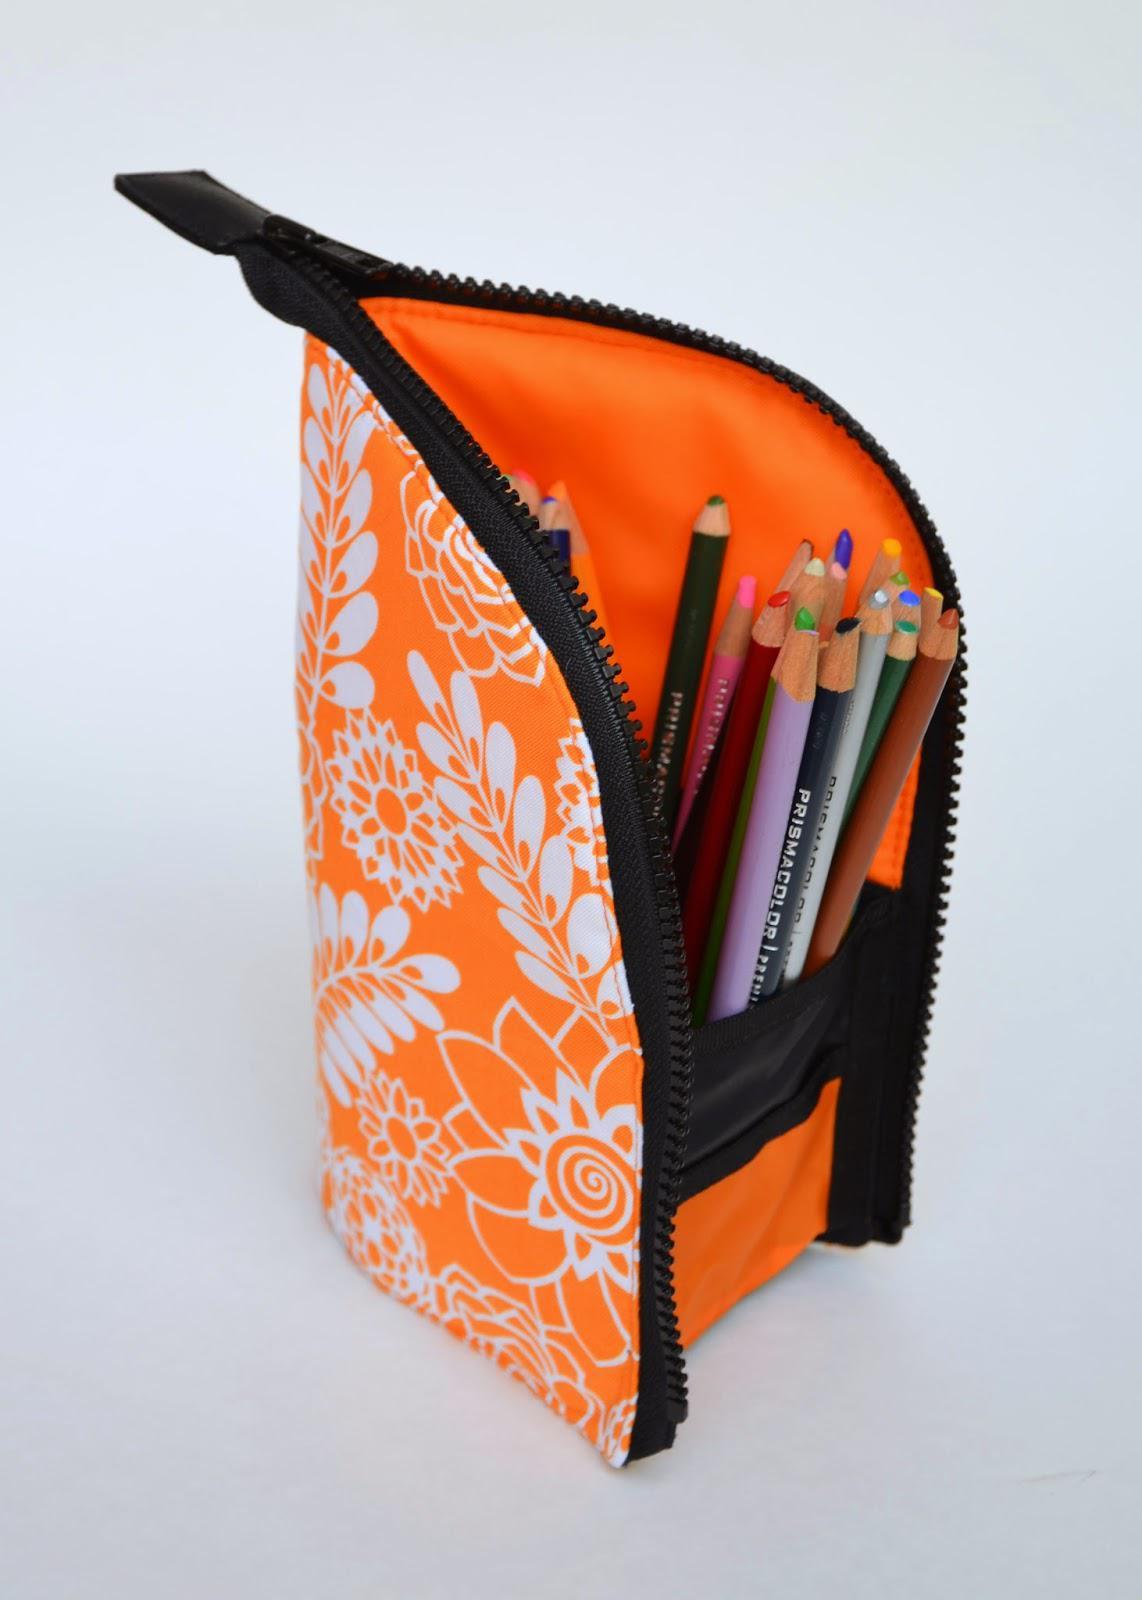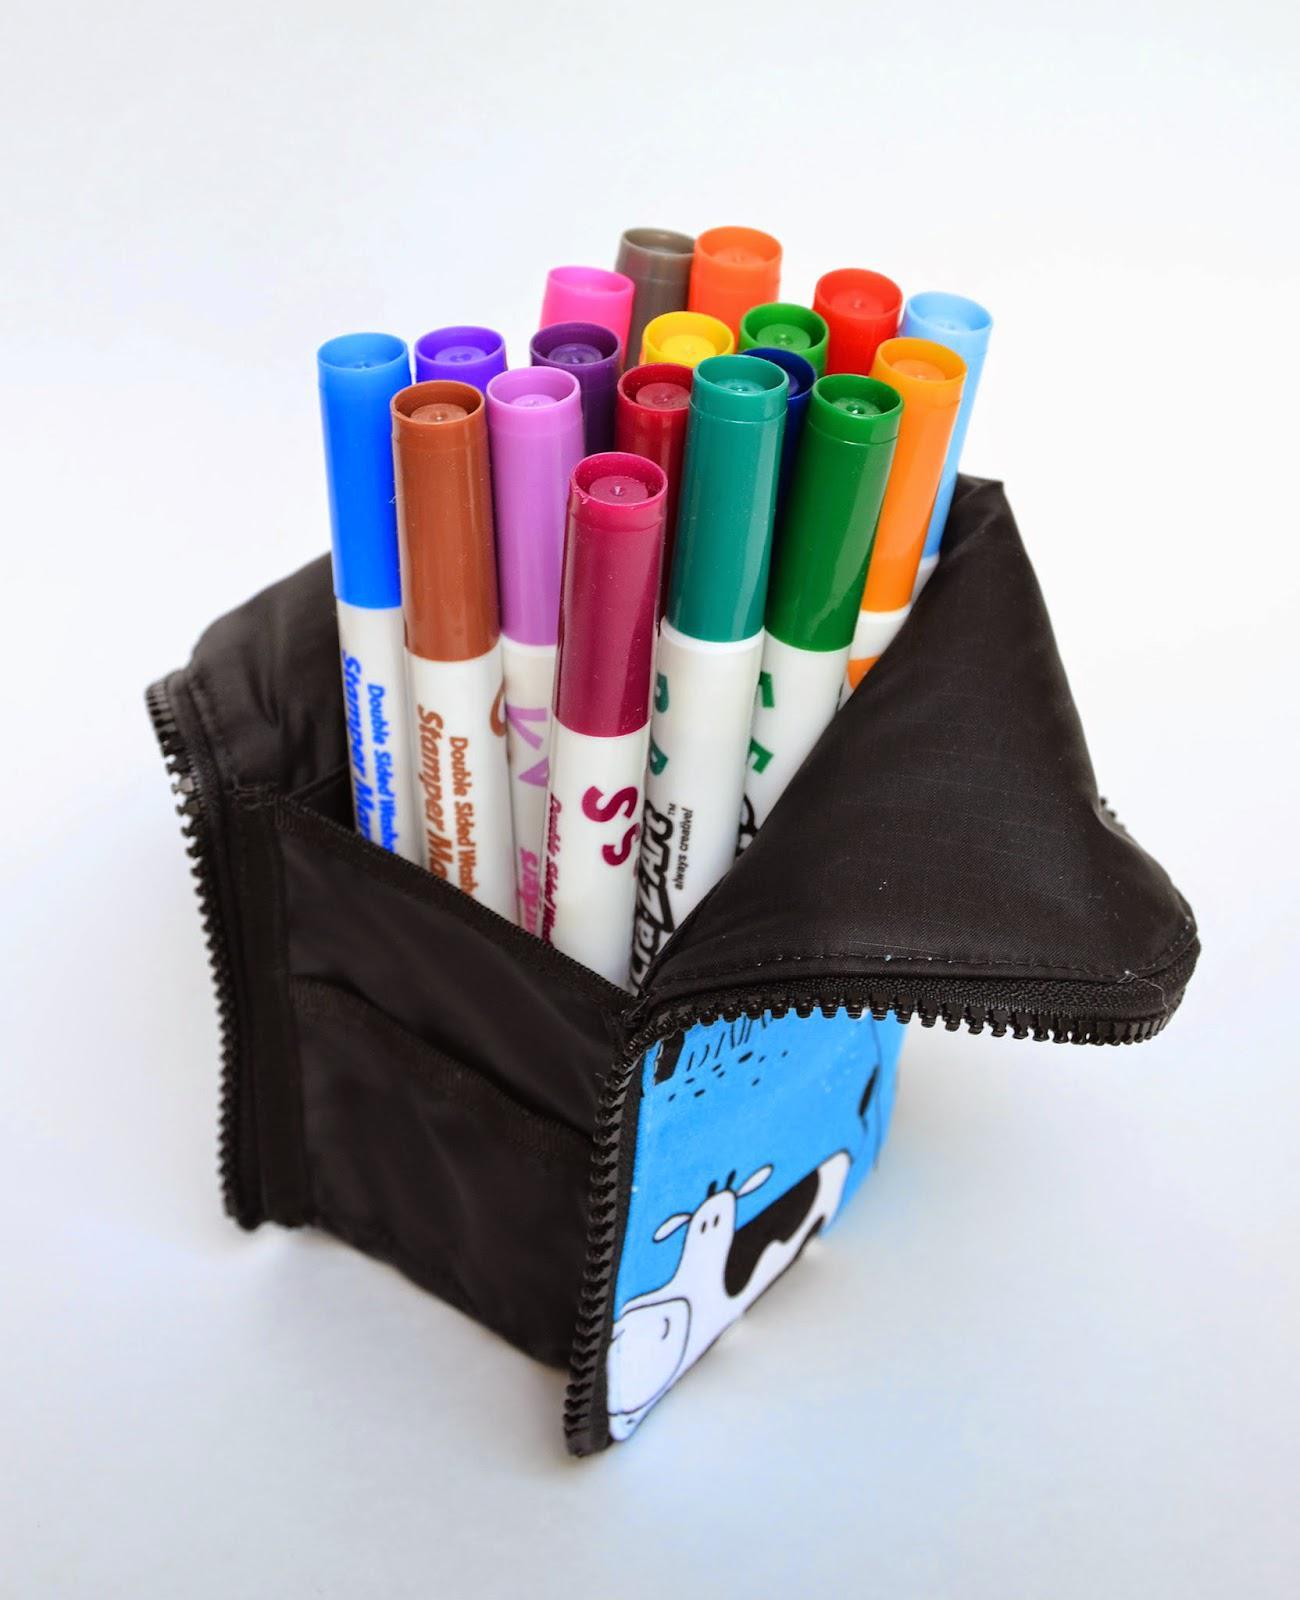The first image is the image on the left, the second image is the image on the right. Assess this claim about the two images: "An image shows an upright pencil pouch with a patterned exterior, filled with only upright colored-lead pencils.". Correct or not? Answer yes or no. Yes. The first image is the image on the left, the second image is the image on the right. Assess this claim about the two images: "There are two pencil holders in the pair of images.". Correct or not? Answer yes or no. Yes. 